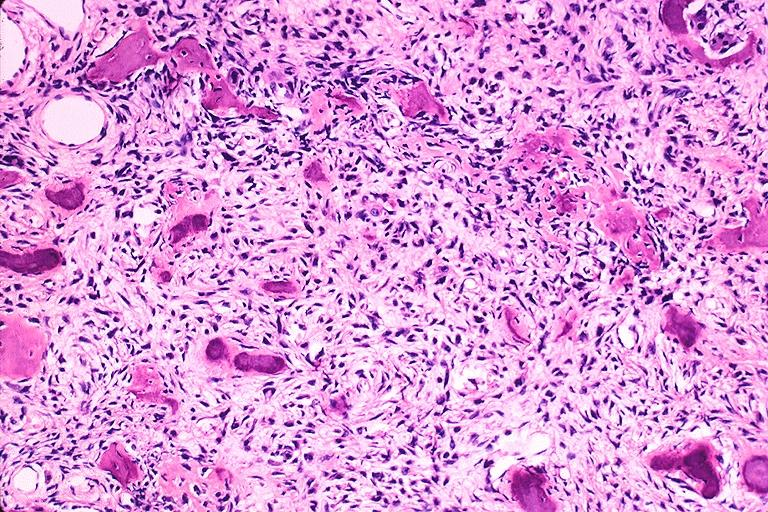s gangrene present?
Answer the question using a single word or phrase. No 